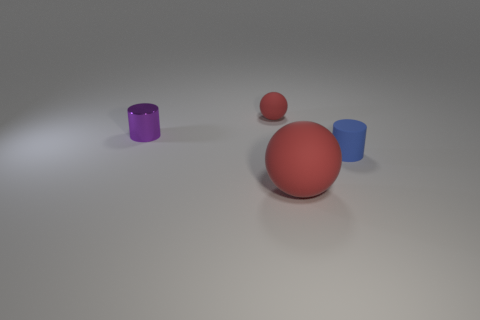What might the colors of the objects suggest? The colors of the objects, which include shades of purple, red, and blue, can suggest a variety of interpretations. They might be arbitrary choices, but they can also be seen as visually stimulating, providing a contrast against the neutral background that potentially highlights their forms and materials. 